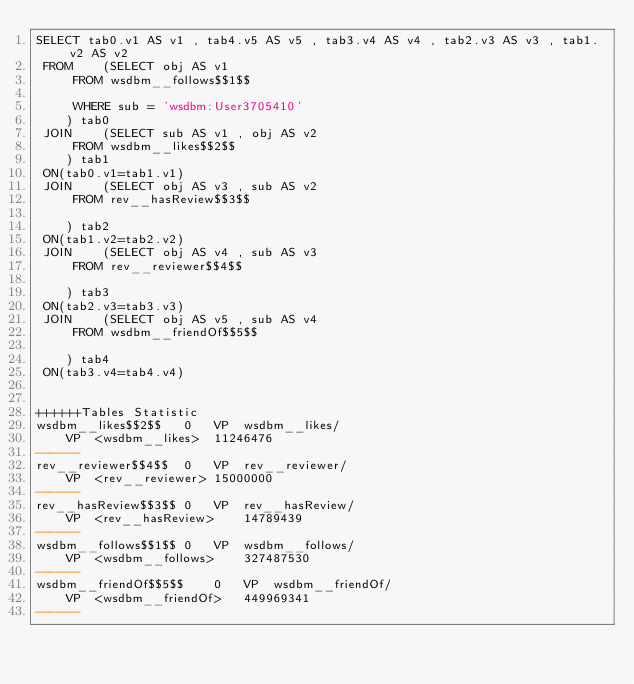<code> <loc_0><loc_0><loc_500><loc_500><_SQL_>SELECT tab0.v1 AS v1 , tab4.v5 AS v5 , tab3.v4 AS v4 , tab2.v3 AS v3 , tab1.v2 AS v2 
 FROM    (SELECT obj AS v1 
	 FROM wsdbm__follows$$1$$
	 
	 WHERE sub = 'wsdbm:User3705410'
	) tab0
 JOIN    (SELECT sub AS v1 , obj AS v2 
	 FROM wsdbm__likes$$2$$
	) tab1
 ON(tab0.v1=tab1.v1)
 JOIN    (SELECT obj AS v3 , sub AS v2 
	 FROM rev__hasReview$$3$$
	
	) tab2
 ON(tab1.v2=tab2.v2)
 JOIN    (SELECT obj AS v4 , sub AS v3 
	 FROM rev__reviewer$$4$$
	
	) tab3
 ON(tab2.v3=tab3.v3)
 JOIN    (SELECT obj AS v5 , sub AS v4 
	 FROM wsdbm__friendOf$$5$$
	
	) tab4
 ON(tab3.v4=tab4.v4)


++++++Tables Statistic
wsdbm__likes$$2$$	0	VP	wsdbm__likes/
	VP	<wsdbm__likes>	11246476
------
rev__reviewer$$4$$	0	VP	rev__reviewer/
	VP	<rev__reviewer>	15000000
------
rev__hasReview$$3$$	0	VP	rev__hasReview/
	VP	<rev__hasReview>	14789439
------
wsdbm__follows$$1$$	0	VP	wsdbm__follows/
	VP	<wsdbm__follows>	327487530
------
wsdbm__friendOf$$5$$	0	VP	wsdbm__friendOf/
	VP	<wsdbm__friendOf>	449969341
------
</code> 